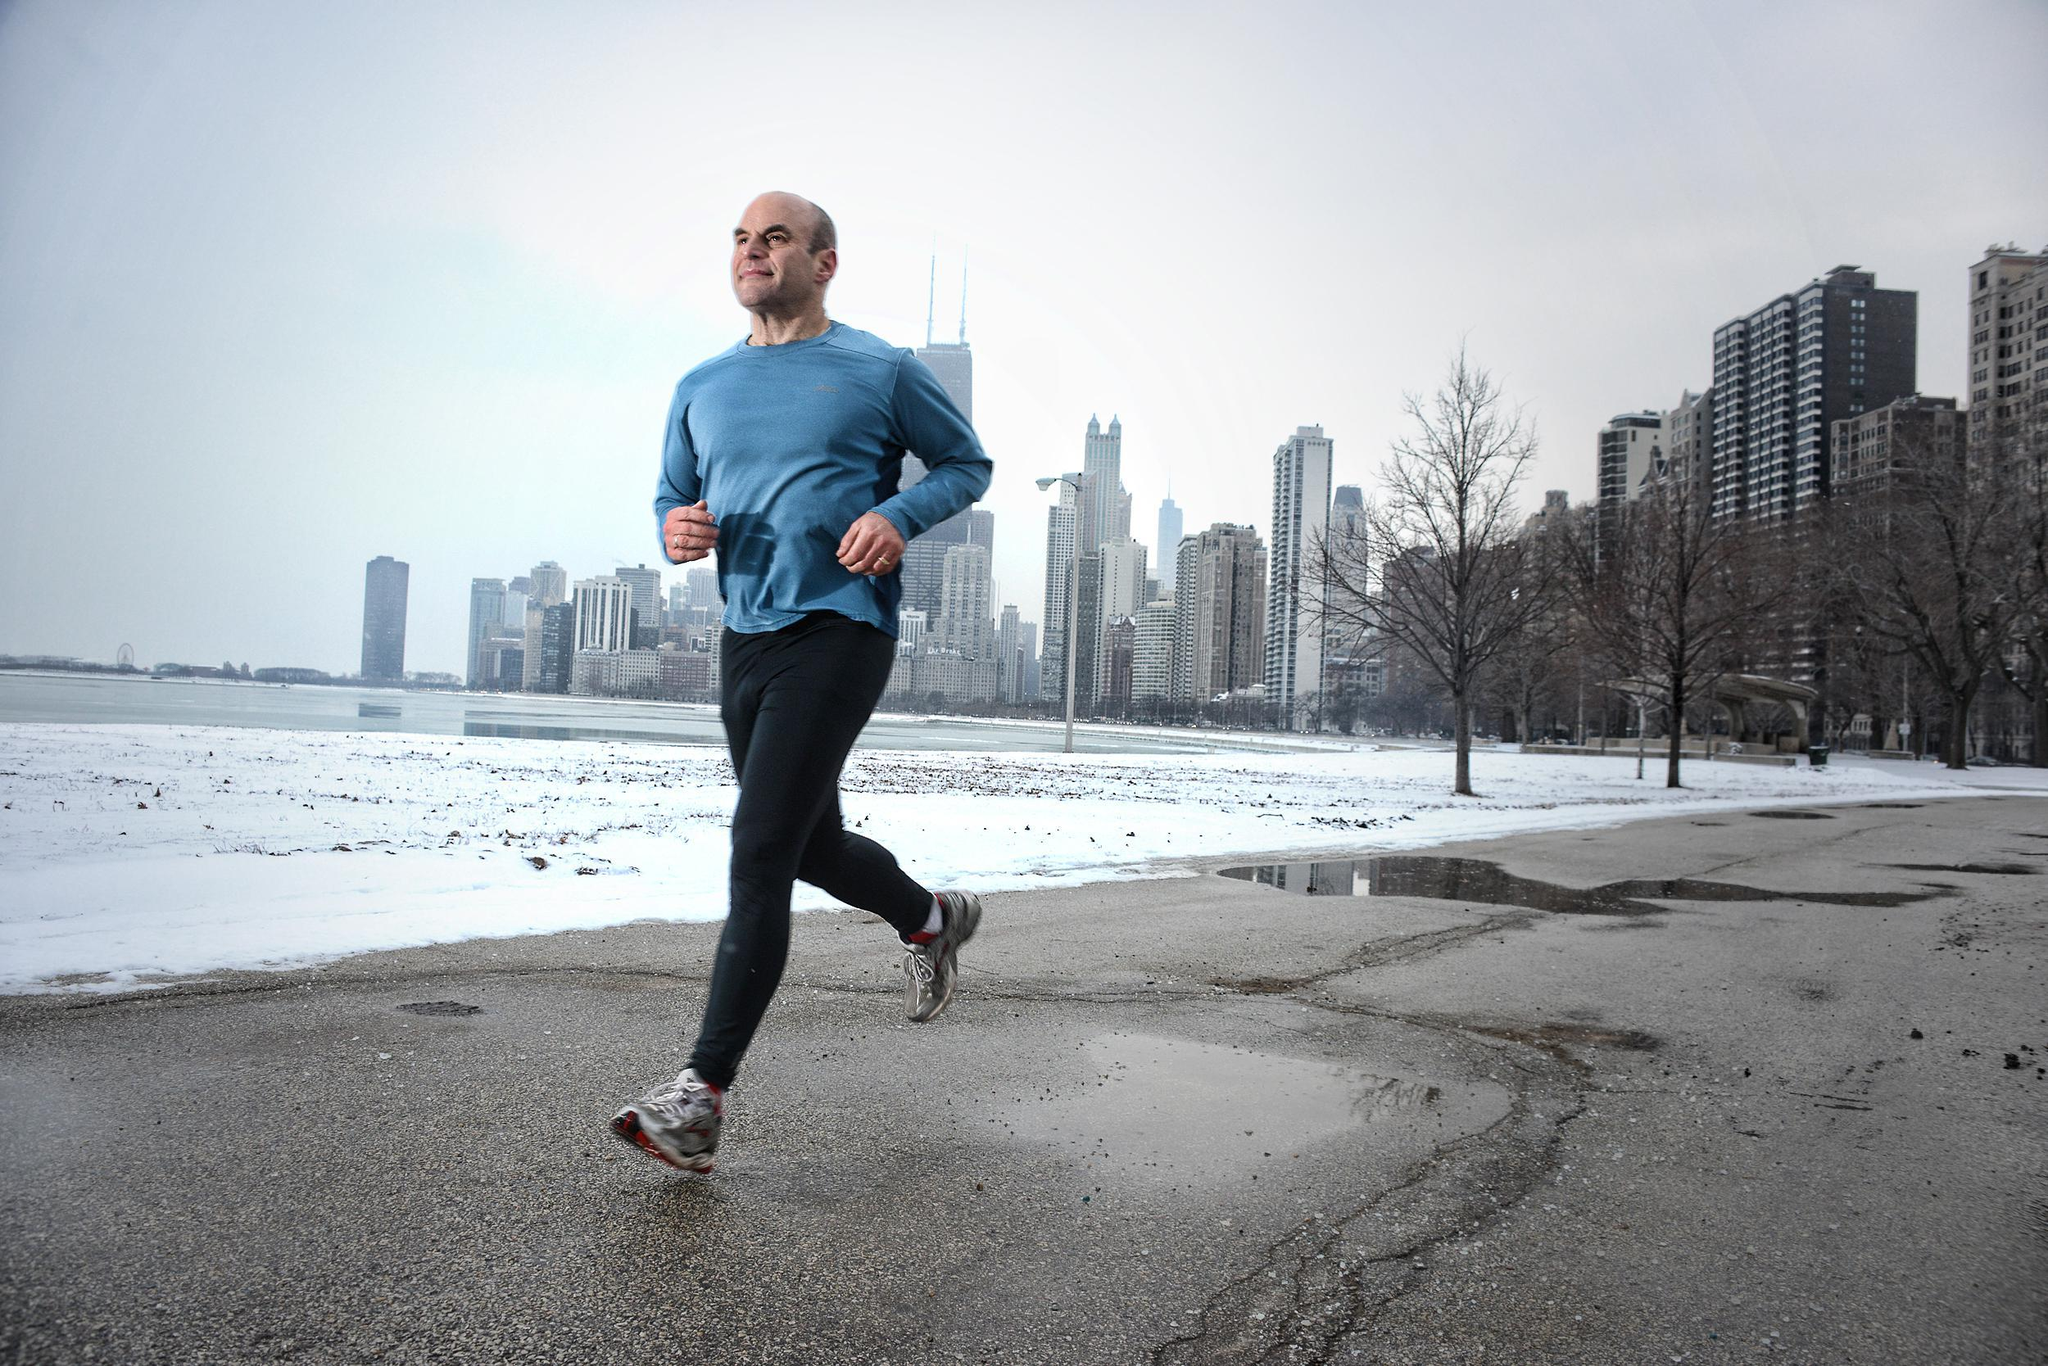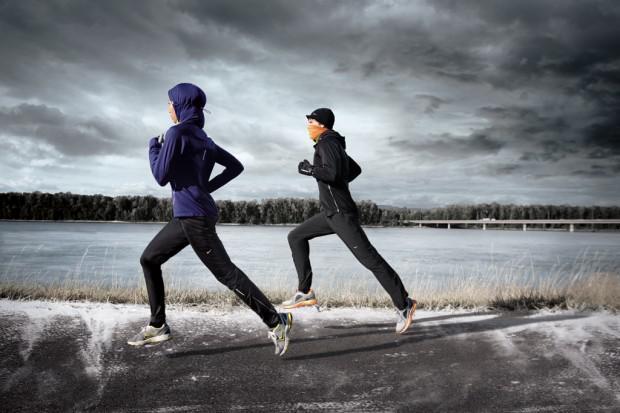The first image is the image on the left, the second image is the image on the right. Evaluate the accuracy of this statement regarding the images: "there is humans in the right side image". Is it true? Answer yes or no. Yes. The first image is the image on the left, the second image is the image on the right. For the images shown, is this caption "In one image there are two people running outside with snow on the ground." true? Answer yes or no. Yes. 